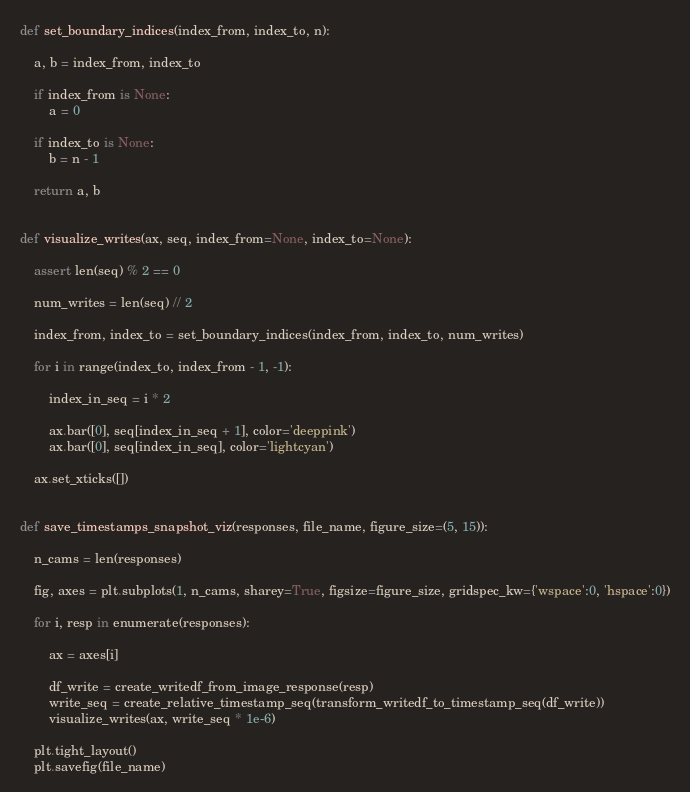Convert code to text. <code><loc_0><loc_0><loc_500><loc_500><_Python_>
def set_boundary_indices(index_from, index_to, n):

    a, b = index_from, index_to

    if index_from is None:
        a = 0

    if index_to is None:
        b = n - 1

    return a, b


def visualize_writes(ax, seq, index_from=None, index_to=None):

    assert len(seq) % 2 == 0

    num_writes = len(seq) // 2

    index_from, index_to = set_boundary_indices(index_from, index_to, num_writes)

    for i in range(index_to, index_from - 1, -1):

        index_in_seq = i * 2

        ax.bar([0], seq[index_in_seq + 1], color='deeppink')
        ax.bar([0], seq[index_in_seq], color='lightcyan')

    ax.set_xticks([])


def save_timestamps_snapshot_viz(responses, file_name, figure_size=(5, 15)):

    n_cams = len(responses)

    fig, axes = plt.subplots(1, n_cams, sharey=True, figsize=figure_size, gridspec_kw={'wspace':0, 'hspace':0})

    for i, resp in enumerate(responses):

        ax = axes[i]

        df_write = create_writedf_from_image_response(resp)
        write_seq = create_relative_timestamp_seq(transform_writedf_to_timestamp_seq(df_write))
        visualize_writes(ax, write_seq * 1e-6)

    plt.tight_layout()
    plt.savefig(file_name)
</code> 